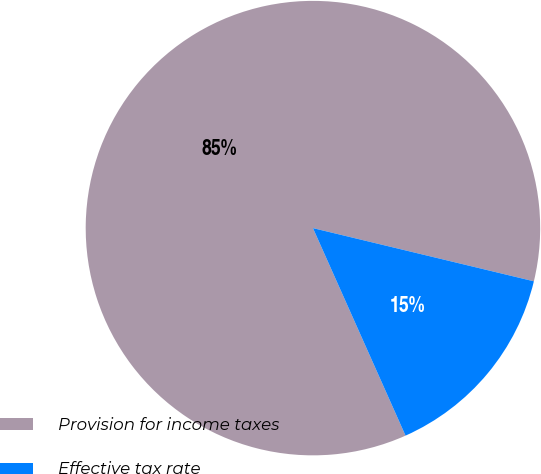<chart> <loc_0><loc_0><loc_500><loc_500><pie_chart><fcel>Provision for income taxes<fcel>Effective tax rate<nl><fcel>85.44%<fcel>14.56%<nl></chart> 